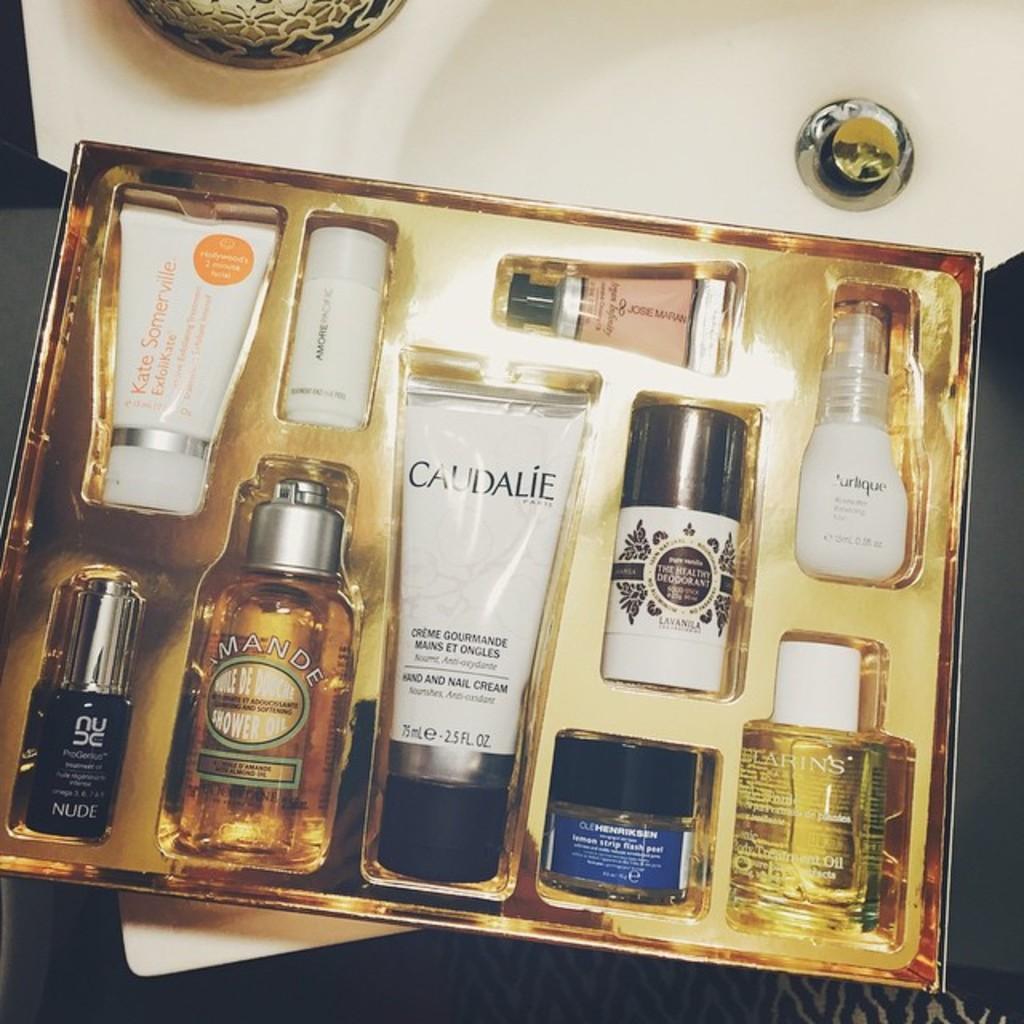What kind of cream is caudalie'?
Offer a terse response. Hand and nail. 